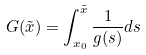<formula> <loc_0><loc_0><loc_500><loc_500>G ( \tilde { x } ) = \int _ { x _ { 0 } } ^ { \tilde { x } } \frac { 1 } { g ( s ) } d s</formula> 